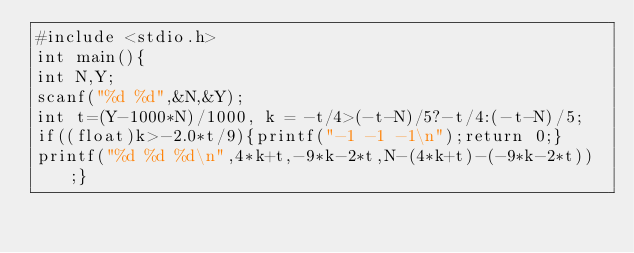<code> <loc_0><loc_0><loc_500><loc_500><_C_>#include <stdio.h>
int main(){
int N,Y;
scanf("%d %d",&N,&Y);
int t=(Y-1000*N)/1000, k = -t/4>(-t-N)/5?-t/4:(-t-N)/5;
if((float)k>-2.0*t/9){printf("-1 -1 -1\n");return 0;}
printf("%d %d %d\n",4*k+t,-9*k-2*t,N-(4*k+t)-(-9*k-2*t));}</code> 